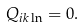<formula> <loc_0><loc_0><loc_500><loc_500>Q _ { i k \ln } = 0 .</formula> 